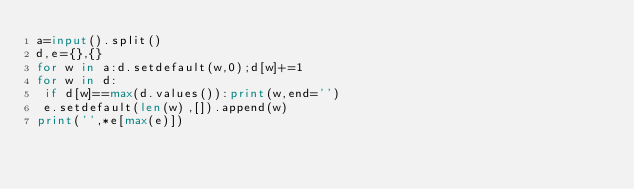<code> <loc_0><loc_0><loc_500><loc_500><_Python_>a=input().split()
d,e={},{}
for w in a:d.setdefault(w,0);d[w]+=1
for w in d:
 if d[w]==max(d.values()):print(w,end='')
 e.setdefault(len(w),[]).append(w)
print('',*e[max(e)])
</code> 